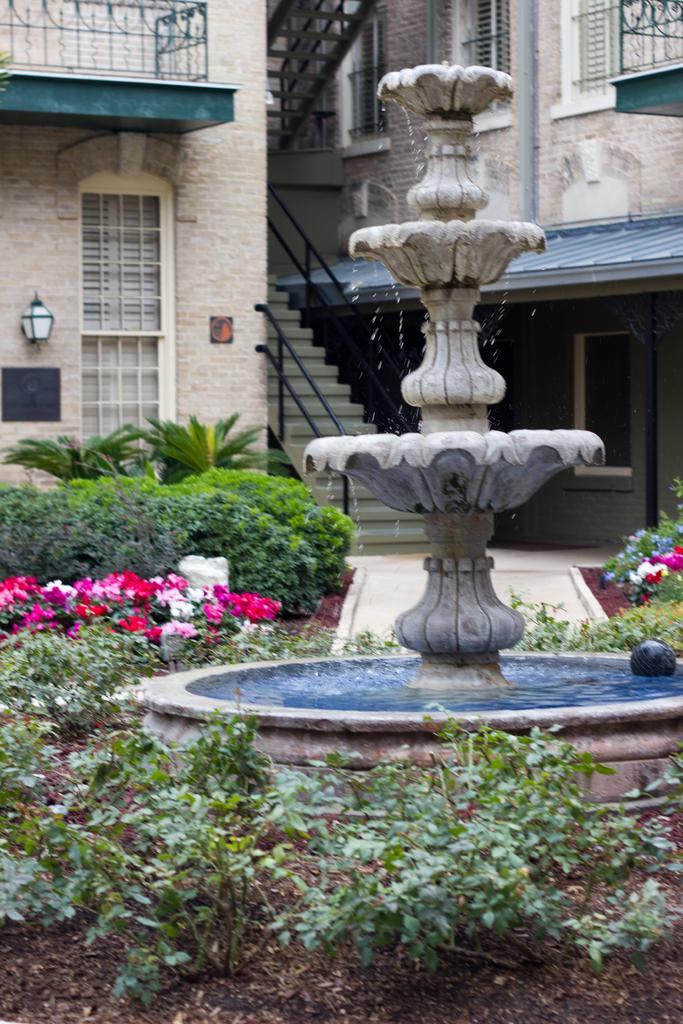What is the main feature in the image? There is a fountain in the image. What else can be seen in the image besides the fountain? There are plants with flowers, a building, and a lamp visible in the image. Can you describe the building in the image? The building has windows, stairs, and a roof. How many cows are grazing near the fountain in the image? There are no cows present in the image; it features a fountain, plants with flowers, and a building. What type of grain is being harvested in the image? There is no grain being harvested in the image; it primarily focuses on the fountain, plants with flowers, and the building. 